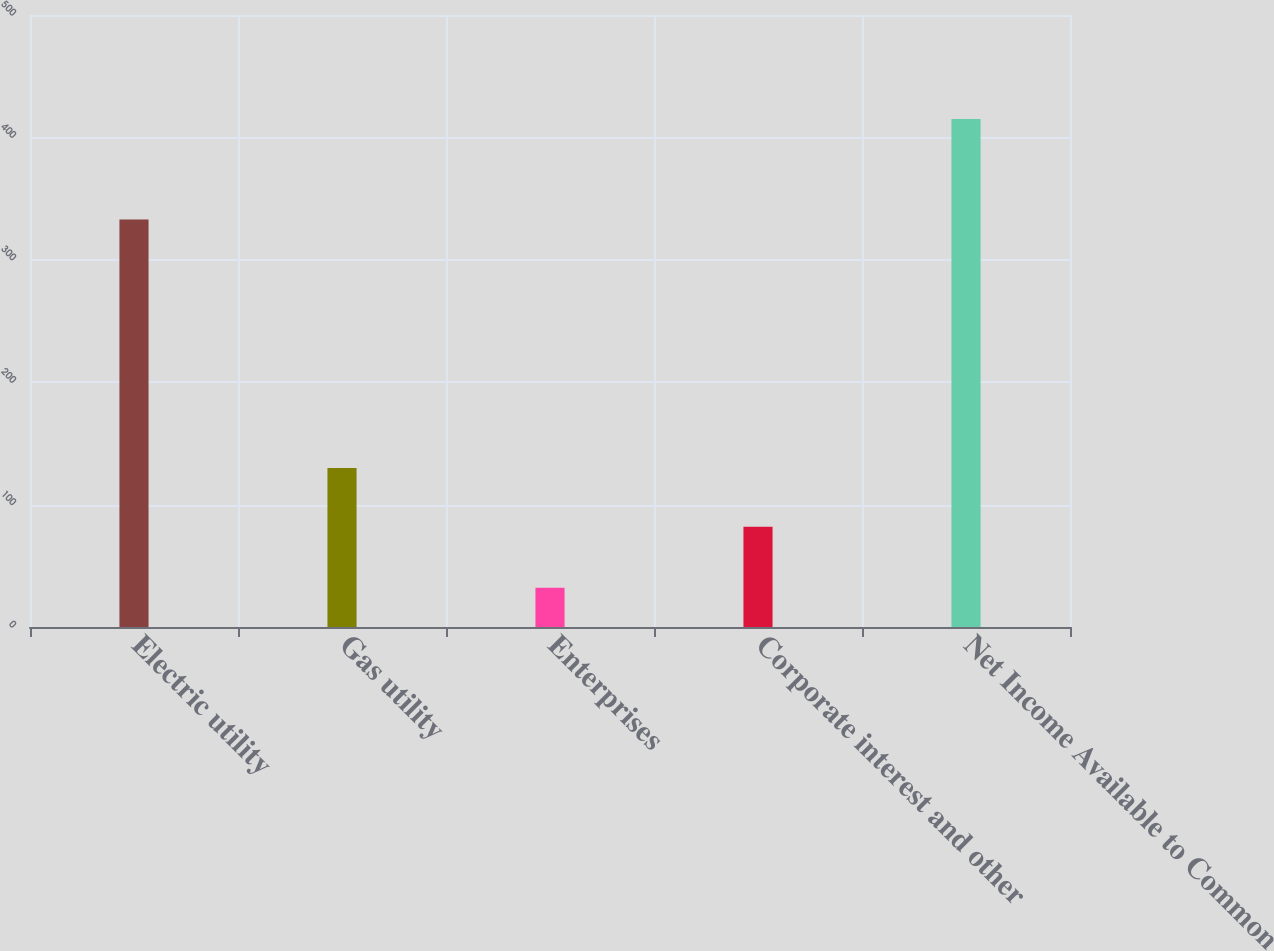Convert chart to OTSL. <chart><loc_0><loc_0><loc_500><loc_500><bar_chart><fcel>Electric utility<fcel>Gas utility<fcel>Enterprises<fcel>Corporate interest and other<fcel>Net Income Available to Common<nl><fcel>333<fcel>130<fcel>32<fcel>82<fcel>415<nl></chart> 